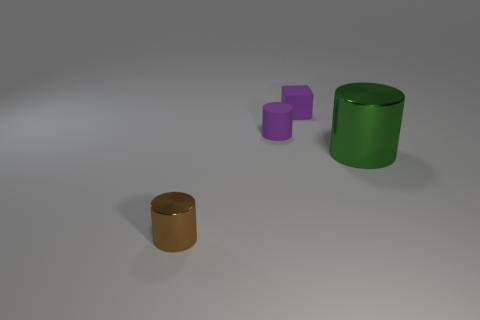Subtract all purple matte cylinders. How many cylinders are left? 2 Subtract 0 brown blocks. How many objects are left? 4 Subtract all cylinders. How many objects are left? 1 Subtract all yellow cylinders. Subtract all red spheres. How many cylinders are left? 3 Subtract all purple spheres. How many green cylinders are left? 1 Subtract all large green metal things. Subtract all large shiny cylinders. How many objects are left? 2 Add 1 rubber cylinders. How many rubber cylinders are left? 2 Add 3 tiny brown things. How many tiny brown things exist? 4 Add 2 small purple cylinders. How many objects exist? 6 